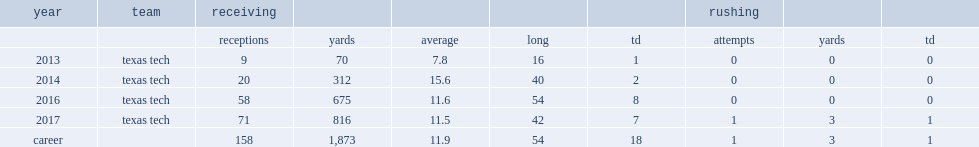How many receptions did cantrell get in 2014? 20.0. Would you mind parsing the complete table? {'header': ['year', 'team', 'receiving', '', '', '', '', 'rushing', '', ''], 'rows': [['', '', 'receptions', 'yards', 'average', 'long', 'td', 'attempts', 'yards', 'td'], ['2013', 'texas tech', '9', '70', '7.8', '16', '1', '0', '0', '0'], ['2014', 'texas tech', '20', '312', '15.6', '40', '2', '0', '0', '0'], ['2016', 'texas tech', '58', '675', '11.6', '54', '8', '0', '0', '0'], ['2017', 'texas tech', '71', '816', '11.5', '42', '7', '1', '3', '1'], ['career', '', '158', '1,873', '11.9', '54', '18', '1', '3', '1']]} 